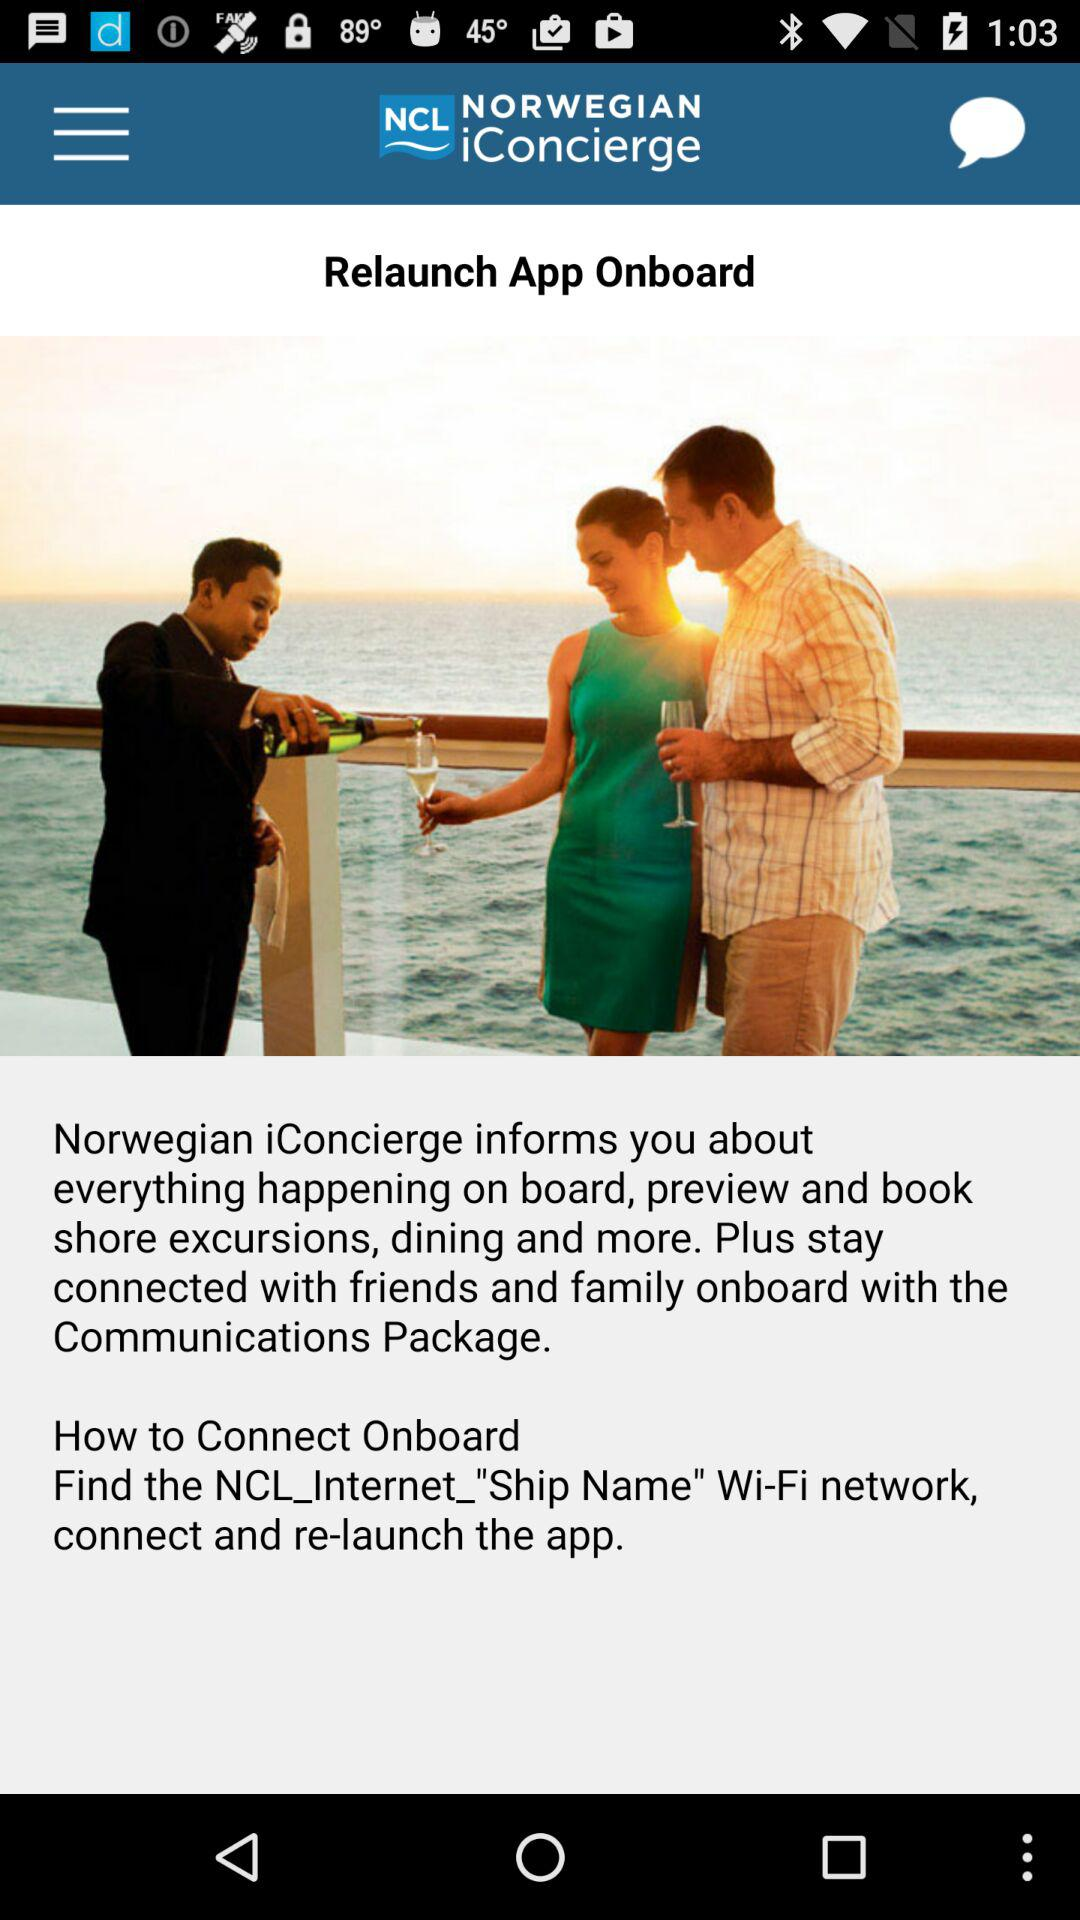What are the options for connecting onboard?
When the provided information is insufficient, respond with <no answer>. <no answer> 